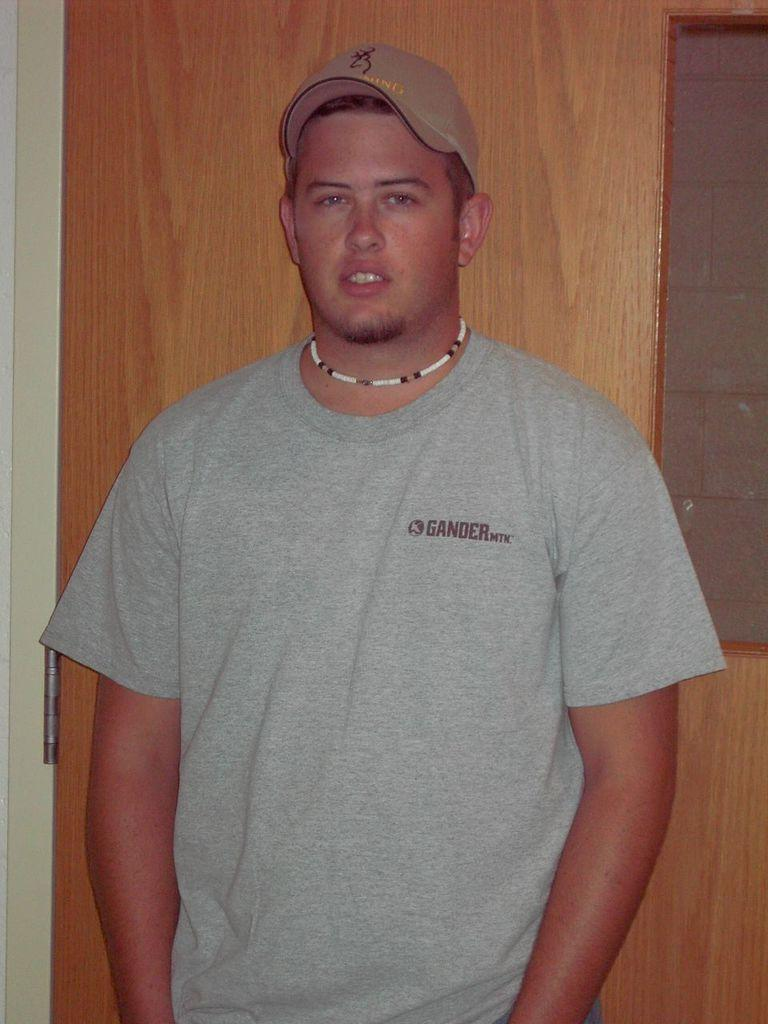Who is present in the image? There is a man in the image. What is the man wearing on his head? The man is wearing a hat. What is the man's posture in the image? The man is standing. What can be seen in the background of the image? There is a wooden wall in the background of the image. What type of flowers can be seen growing on the edge of the wooden wall in the image? There are no flowers visible in the image, and the wooden wall does not have an edge. 